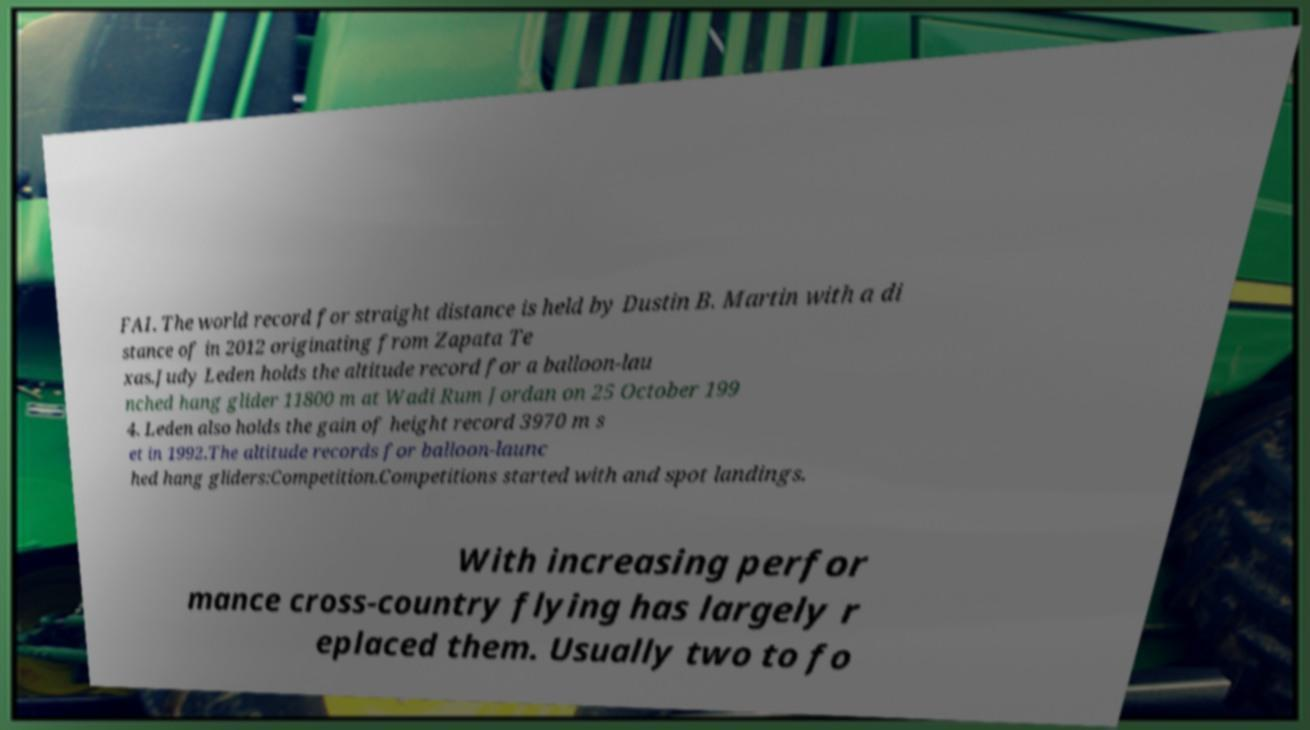What messages or text are displayed in this image? I need them in a readable, typed format. FAI. The world record for straight distance is held by Dustin B. Martin with a di stance of in 2012 originating from Zapata Te xas.Judy Leden holds the altitude record for a balloon-lau nched hang glider 11800 m at Wadi Rum Jordan on 25 October 199 4. Leden also holds the gain of height record 3970 m s et in 1992.The altitude records for balloon-launc hed hang gliders:Competition.Competitions started with and spot landings. With increasing perfor mance cross-country flying has largely r eplaced them. Usually two to fo 